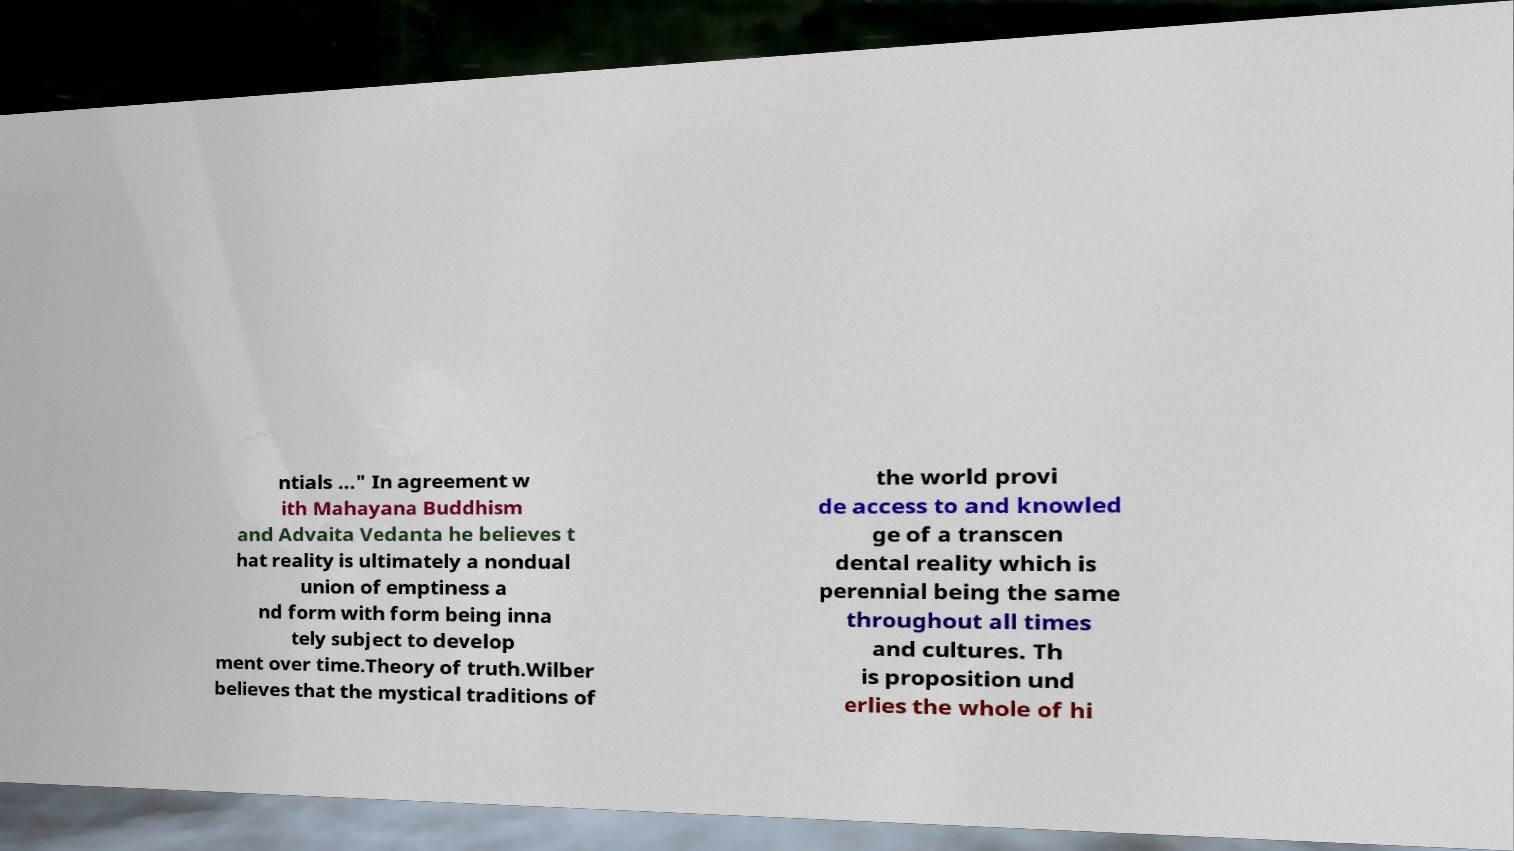Can you accurately transcribe the text from the provided image for me? ntials ..." In agreement w ith Mahayana Buddhism and Advaita Vedanta he believes t hat reality is ultimately a nondual union of emptiness a nd form with form being inna tely subject to develop ment over time.Theory of truth.Wilber believes that the mystical traditions of the world provi de access to and knowled ge of a transcen dental reality which is perennial being the same throughout all times and cultures. Th is proposition und erlies the whole of hi 